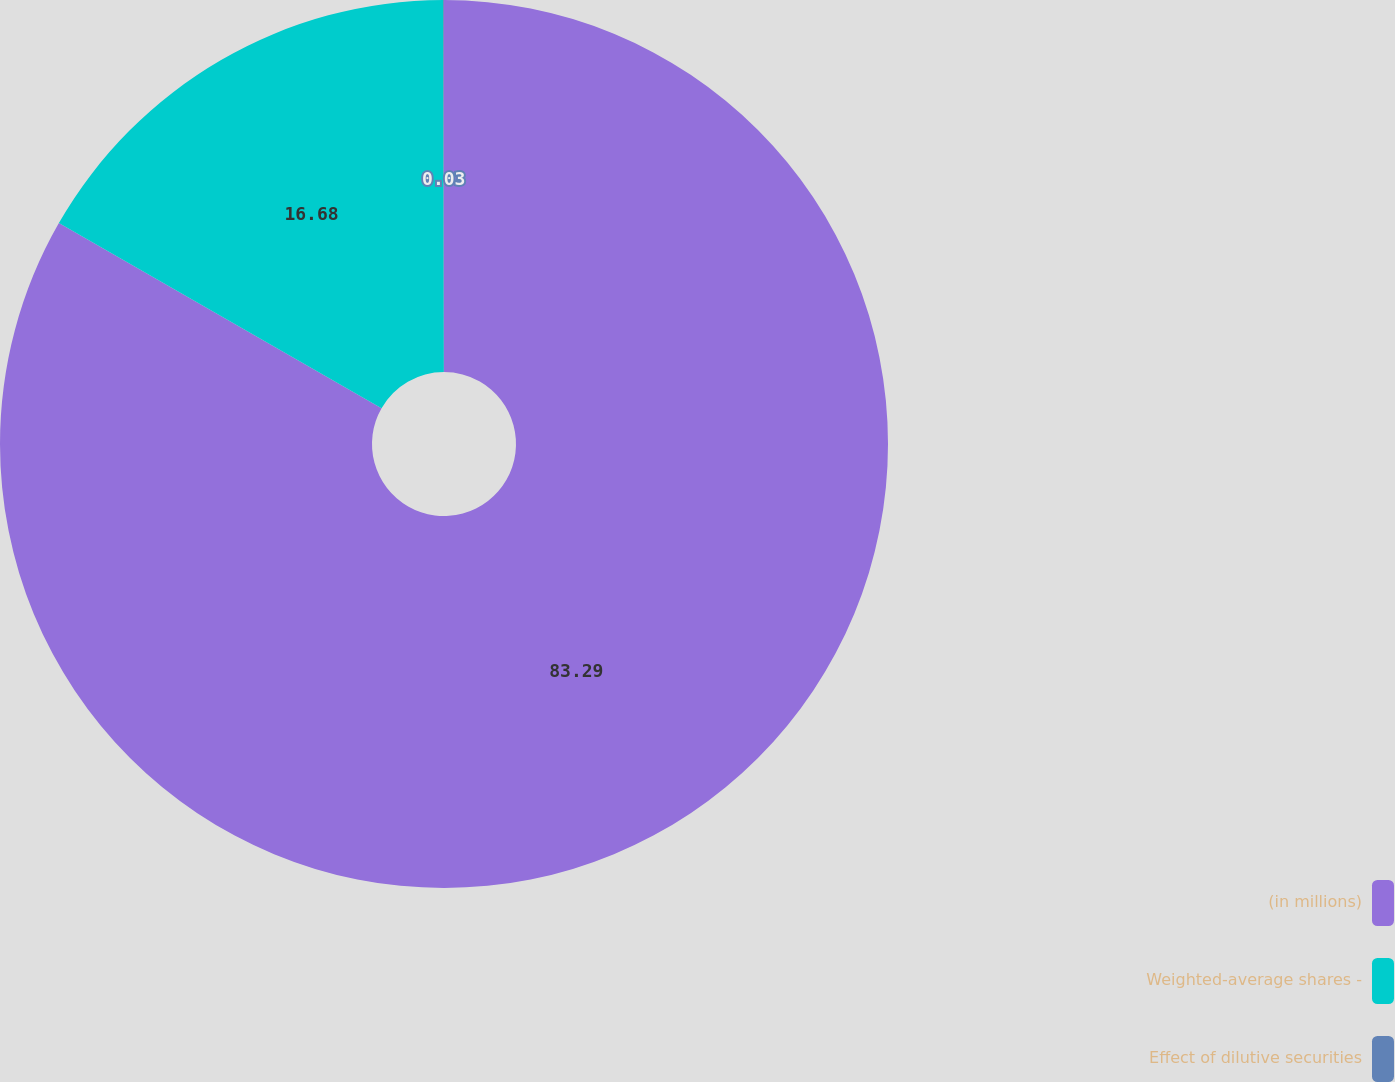<chart> <loc_0><loc_0><loc_500><loc_500><pie_chart><fcel>(in millions)<fcel>Weighted-average shares -<fcel>Effect of dilutive securities<nl><fcel>83.29%<fcel>16.68%<fcel>0.03%<nl></chart> 